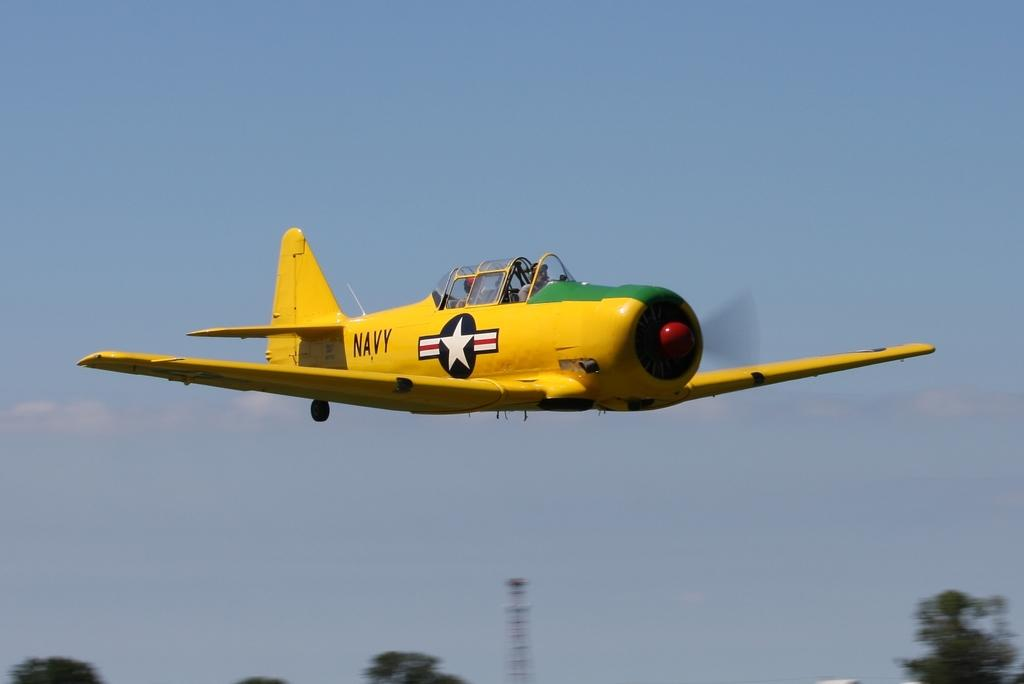<image>
Create a compact narrative representing the image presented. A yellow and green Navy open cockpit plane flying low. 